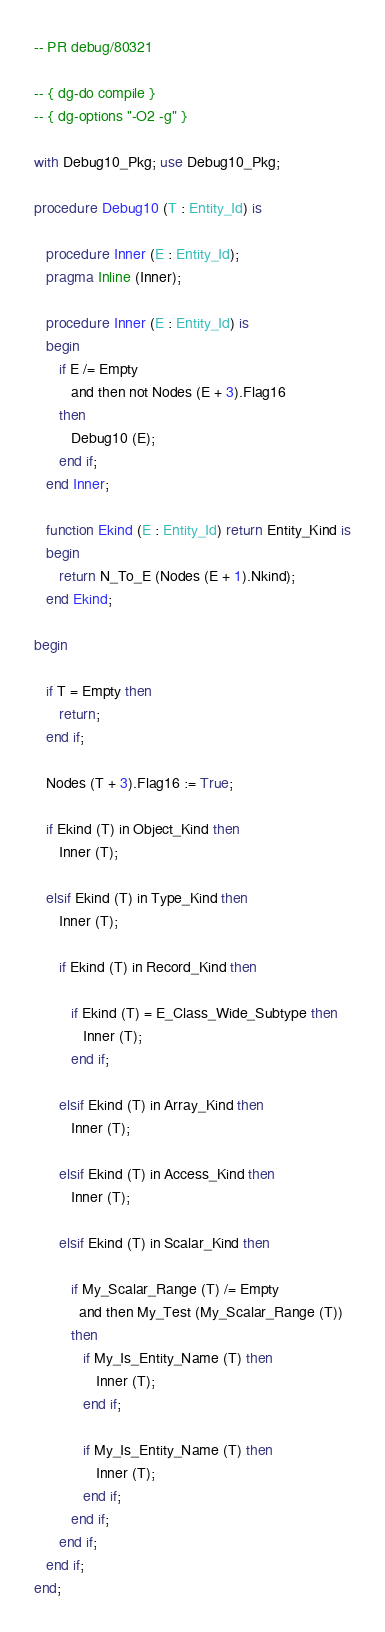<code> <loc_0><loc_0><loc_500><loc_500><_Ada_>-- PR debug/80321

-- { dg-do compile }
-- { dg-options "-O2 -g" }

with Debug10_Pkg; use Debug10_Pkg;

procedure Debug10 (T : Entity_Id) is

   procedure Inner (E : Entity_Id);
   pragma Inline (Inner);

   procedure Inner (E : Entity_Id) is
   begin
      if E /= Empty
         and then not Nodes (E + 3).Flag16
      then
         Debug10 (E);
      end if;
   end Inner;

   function Ekind (E : Entity_Id) return Entity_Kind is
   begin
      return N_To_E (Nodes (E + 1).Nkind);
   end Ekind;

begin

   if T = Empty then
      return;
   end if;

   Nodes (T + 3).Flag16 := True;

   if Ekind (T) in Object_Kind then
      Inner (T);

   elsif Ekind (T) in Type_Kind then
      Inner (T);

      if Ekind (T) in Record_Kind then

         if Ekind (T) = E_Class_Wide_Subtype then
            Inner (T);
         end if;

      elsif Ekind (T) in Array_Kind then
         Inner (T);

      elsif Ekind (T) in Access_Kind then
         Inner (T);

      elsif Ekind (T) in Scalar_Kind then

         if My_Scalar_Range (T) /= Empty
           and then My_Test (My_Scalar_Range (T))
         then
            if My_Is_Entity_Name (T) then
               Inner (T);
            end if;

            if My_Is_Entity_Name (T) then
               Inner (T);
            end if;
         end if;
      end if;
   end if;
end;
</code> 